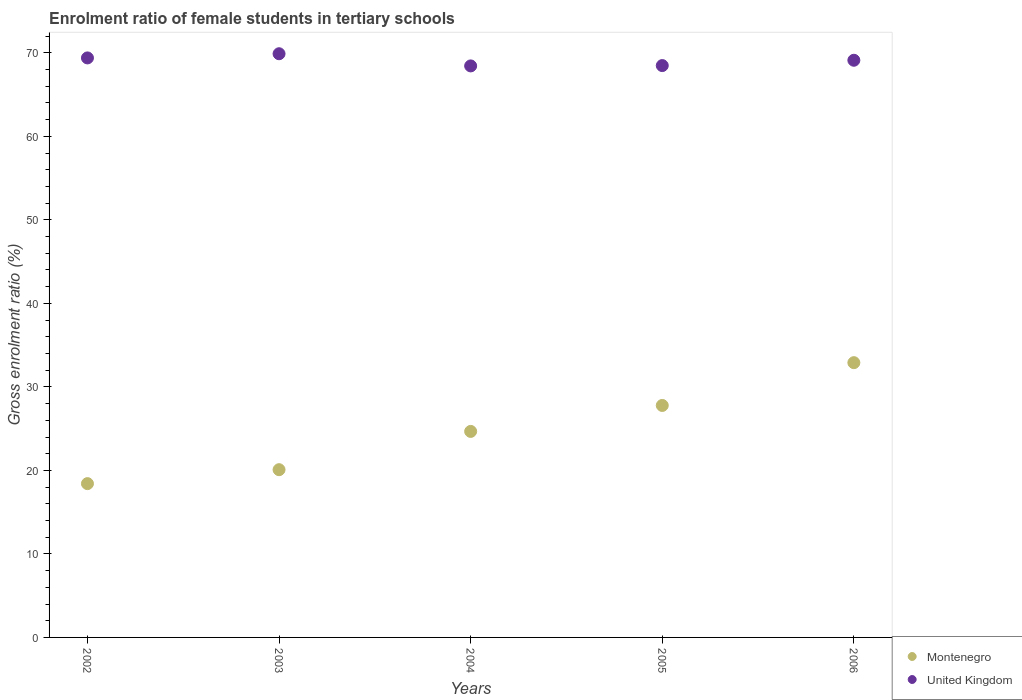Is the number of dotlines equal to the number of legend labels?
Ensure brevity in your answer.  Yes. What is the enrolment ratio of female students in tertiary schools in Montenegro in 2003?
Make the answer very short. 20.09. Across all years, what is the maximum enrolment ratio of female students in tertiary schools in United Kingdom?
Ensure brevity in your answer.  69.9. Across all years, what is the minimum enrolment ratio of female students in tertiary schools in Montenegro?
Make the answer very short. 18.42. In which year was the enrolment ratio of female students in tertiary schools in United Kingdom minimum?
Provide a succinct answer. 2004. What is the total enrolment ratio of female students in tertiary schools in United Kingdom in the graph?
Offer a terse response. 345.32. What is the difference between the enrolment ratio of female students in tertiary schools in Montenegro in 2002 and that in 2003?
Your answer should be compact. -1.67. What is the difference between the enrolment ratio of female students in tertiary schools in Montenegro in 2002 and the enrolment ratio of female students in tertiary schools in United Kingdom in 2003?
Make the answer very short. -51.48. What is the average enrolment ratio of female students in tertiary schools in United Kingdom per year?
Offer a terse response. 69.06. In the year 2003, what is the difference between the enrolment ratio of female students in tertiary schools in United Kingdom and enrolment ratio of female students in tertiary schools in Montenegro?
Offer a very short reply. 49.81. What is the ratio of the enrolment ratio of female students in tertiary schools in United Kingdom in 2003 to that in 2006?
Your response must be concise. 1.01. What is the difference between the highest and the second highest enrolment ratio of female students in tertiary schools in Montenegro?
Offer a terse response. 5.12. What is the difference between the highest and the lowest enrolment ratio of female students in tertiary schools in Montenegro?
Provide a succinct answer. 14.49. In how many years, is the enrolment ratio of female students in tertiary schools in United Kingdom greater than the average enrolment ratio of female students in tertiary schools in United Kingdom taken over all years?
Your answer should be compact. 3. Is the sum of the enrolment ratio of female students in tertiary schools in Montenegro in 2003 and 2005 greater than the maximum enrolment ratio of female students in tertiary schools in United Kingdom across all years?
Your answer should be compact. No. Does the enrolment ratio of female students in tertiary schools in United Kingdom monotonically increase over the years?
Offer a very short reply. No. How many dotlines are there?
Your response must be concise. 2. How many years are there in the graph?
Your response must be concise. 5. What is the difference between two consecutive major ticks on the Y-axis?
Keep it short and to the point. 10. Are the values on the major ticks of Y-axis written in scientific E-notation?
Offer a terse response. No. Does the graph contain any zero values?
Your response must be concise. No. Does the graph contain grids?
Your answer should be compact. No. How many legend labels are there?
Give a very brief answer. 2. What is the title of the graph?
Make the answer very short. Enrolment ratio of female students in tertiary schools. Does "Sudan" appear as one of the legend labels in the graph?
Your response must be concise. No. What is the label or title of the Y-axis?
Offer a very short reply. Gross enrolment ratio (%). What is the Gross enrolment ratio (%) in Montenegro in 2002?
Your response must be concise. 18.42. What is the Gross enrolment ratio (%) of United Kingdom in 2002?
Offer a very short reply. 69.4. What is the Gross enrolment ratio (%) of Montenegro in 2003?
Your response must be concise. 20.09. What is the Gross enrolment ratio (%) of United Kingdom in 2003?
Provide a succinct answer. 69.9. What is the Gross enrolment ratio (%) of Montenegro in 2004?
Keep it short and to the point. 24.67. What is the Gross enrolment ratio (%) in United Kingdom in 2004?
Make the answer very short. 68.44. What is the Gross enrolment ratio (%) of Montenegro in 2005?
Give a very brief answer. 27.78. What is the Gross enrolment ratio (%) of United Kingdom in 2005?
Offer a terse response. 68.48. What is the Gross enrolment ratio (%) in Montenegro in 2006?
Keep it short and to the point. 32.9. What is the Gross enrolment ratio (%) of United Kingdom in 2006?
Give a very brief answer. 69.11. Across all years, what is the maximum Gross enrolment ratio (%) of Montenegro?
Provide a succinct answer. 32.9. Across all years, what is the maximum Gross enrolment ratio (%) of United Kingdom?
Give a very brief answer. 69.9. Across all years, what is the minimum Gross enrolment ratio (%) of Montenegro?
Make the answer very short. 18.42. Across all years, what is the minimum Gross enrolment ratio (%) of United Kingdom?
Keep it short and to the point. 68.44. What is the total Gross enrolment ratio (%) in Montenegro in the graph?
Your answer should be compact. 123.85. What is the total Gross enrolment ratio (%) of United Kingdom in the graph?
Ensure brevity in your answer.  345.32. What is the difference between the Gross enrolment ratio (%) in Montenegro in 2002 and that in 2003?
Your answer should be very brief. -1.67. What is the difference between the Gross enrolment ratio (%) of United Kingdom in 2002 and that in 2003?
Your answer should be compact. -0.5. What is the difference between the Gross enrolment ratio (%) of Montenegro in 2002 and that in 2004?
Keep it short and to the point. -6.25. What is the difference between the Gross enrolment ratio (%) in United Kingdom in 2002 and that in 2004?
Your answer should be very brief. 0.96. What is the difference between the Gross enrolment ratio (%) of Montenegro in 2002 and that in 2005?
Make the answer very short. -9.36. What is the difference between the Gross enrolment ratio (%) of United Kingdom in 2002 and that in 2005?
Offer a terse response. 0.92. What is the difference between the Gross enrolment ratio (%) of Montenegro in 2002 and that in 2006?
Offer a terse response. -14.49. What is the difference between the Gross enrolment ratio (%) of United Kingdom in 2002 and that in 2006?
Your response must be concise. 0.28. What is the difference between the Gross enrolment ratio (%) in Montenegro in 2003 and that in 2004?
Your answer should be very brief. -4.58. What is the difference between the Gross enrolment ratio (%) of United Kingdom in 2003 and that in 2004?
Keep it short and to the point. 1.46. What is the difference between the Gross enrolment ratio (%) of Montenegro in 2003 and that in 2005?
Make the answer very short. -7.69. What is the difference between the Gross enrolment ratio (%) in United Kingdom in 2003 and that in 2005?
Offer a very short reply. 1.42. What is the difference between the Gross enrolment ratio (%) in Montenegro in 2003 and that in 2006?
Provide a short and direct response. -12.82. What is the difference between the Gross enrolment ratio (%) of United Kingdom in 2003 and that in 2006?
Keep it short and to the point. 0.78. What is the difference between the Gross enrolment ratio (%) in Montenegro in 2004 and that in 2005?
Provide a succinct answer. -3.11. What is the difference between the Gross enrolment ratio (%) in United Kingdom in 2004 and that in 2005?
Keep it short and to the point. -0.04. What is the difference between the Gross enrolment ratio (%) in Montenegro in 2004 and that in 2006?
Provide a succinct answer. -8.23. What is the difference between the Gross enrolment ratio (%) in United Kingdom in 2004 and that in 2006?
Your answer should be very brief. -0.68. What is the difference between the Gross enrolment ratio (%) in Montenegro in 2005 and that in 2006?
Your answer should be compact. -5.12. What is the difference between the Gross enrolment ratio (%) of United Kingdom in 2005 and that in 2006?
Provide a succinct answer. -0.64. What is the difference between the Gross enrolment ratio (%) of Montenegro in 2002 and the Gross enrolment ratio (%) of United Kingdom in 2003?
Offer a very short reply. -51.48. What is the difference between the Gross enrolment ratio (%) in Montenegro in 2002 and the Gross enrolment ratio (%) in United Kingdom in 2004?
Offer a very short reply. -50.02. What is the difference between the Gross enrolment ratio (%) of Montenegro in 2002 and the Gross enrolment ratio (%) of United Kingdom in 2005?
Provide a short and direct response. -50.06. What is the difference between the Gross enrolment ratio (%) of Montenegro in 2002 and the Gross enrolment ratio (%) of United Kingdom in 2006?
Offer a very short reply. -50.7. What is the difference between the Gross enrolment ratio (%) in Montenegro in 2003 and the Gross enrolment ratio (%) in United Kingdom in 2004?
Your answer should be compact. -48.35. What is the difference between the Gross enrolment ratio (%) in Montenegro in 2003 and the Gross enrolment ratio (%) in United Kingdom in 2005?
Provide a short and direct response. -48.39. What is the difference between the Gross enrolment ratio (%) in Montenegro in 2003 and the Gross enrolment ratio (%) in United Kingdom in 2006?
Provide a succinct answer. -49.03. What is the difference between the Gross enrolment ratio (%) in Montenegro in 2004 and the Gross enrolment ratio (%) in United Kingdom in 2005?
Offer a very short reply. -43.81. What is the difference between the Gross enrolment ratio (%) of Montenegro in 2004 and the Gross enrolment ratio (%) of United Kingdom in 2006?
Keep it short and to the point. -44.44. What is the difference between the Gross enrolment ratio (%) in Montenegro in 2005 and the Gross enrolment ratio (%) in United Kingdom in 2006?
Keep it short and to the point. -41.34. What is the average Gross enrolment ratio (%) of Montenegro per year?
Your answer should be very brief. 24.77. What is the average Gross enrolment ratio (%) in United Kingdom per year?
Offer a terse response. 69.06. In the year 2002, what is the difference between the Gross enrolment ratio (%) in Montenegro and Gross enrolment ratio (%) in United Kingdom?
Offer a very short reply. -50.98. In the year 2003, what is the difference between the Gross enrolment ratio (%) of Montenegro and Gross enrolment ratio (%) of United Kingdom?
Provide a short and direct response. -49.81. In the year 2004, what is the difference between the Gross enrolment ratio (%) in Montenegro and Gross enrolment ratio (%) in United Kingdom?
Ensure brevity in your answer.  -43.77. In the year 2005, what is the difference between the Gross enrolment ratio (%) of Montenegro and Gross enrolment ratio (%) of United Kingdom?
Give a very brief answer. -40.7. In the year 2006, what is the difference between the Gross enrolment ratio (%) in Montenegro and Gross enrolment ratio (%) in United Kingdom?
Provide a short and direct response. -36.21. What is the ratio of the Gross enrolment ratio (%) in Montenegro in 2002 to that in 2003?
Your answer should be very brief. 0.92. What is the ratio of the Gross enrolment ratio (%) of United Kingdom in 2002 to that in 2003?
Provide a short and direct response. 0.99. What is the ratio of the Gross enrolment ratio (%) of Montenegro in 2002 to that in 2004?
Your answer should be very brief. 0.75. What is the ratio of the Gross enrolment ratio (%) of Montenegro in 2002 to that in 2005?
Make the answer very short. 0.66. What is the ratio of the Gross enrolment ratio (%) in United Kingdom in 2002 to that in 2005?
Make the answer very short. 1.01. What is the ratio of the Gross enrolment ratio (%) in Montenegro in 2002 to that in 2006?
Provide a succinct answer. 0.56. What is the ratio of the Gross enrolment ratio (%) in Montenegro in 2003 to that in 2004?
Make the answer very short. 0.81. What is the ratio of the Gross enrolment ratio (%) of United Kingdom in 2003 to that in 2004?
Your response must be concise. 1.02. What is the ratio of the Gross enrolment ratio (%) in Montenegro in 2003 to that in 2005?
Your answer should be compact. 0.72. What is the ratio of the Gross enrolment ratio (%) of United Kingdom in 2003 to that in 2005?
Keep it short and to the point. 1.02. What is the ratio of the Gross enrolment ratio (%) of Montenegro in 2003 to that in 2006?
Provide a short and direct response. 0.61. What is the ratio of the Gross enrolment ratio (%) of United Kingdom in 2003 to that in 2006?
Make the answer very short. 1.01. What is the ratio of the Gross enrolment ratio (%) of Montenegro in 2004 to that in 2005?
Your answer should be very brief. 0.89. What is the ratio of the Gross enrolment ratio (%) in United Kingdom in 2004 to that in 2005?
Offer a very short reply. 1. What is the ratio of the Gross enrolment ratio (%) of Montenegro in 2004 to that in 2006?
Your answer should be very brief. 0.75. What is the ratio of the Gross enrolment ratio (%) of United Kingdom in 2004 to that in 2006?
Ensure brevity in your answer.  0.99. What is the ratio of the Gross enrolment ratio (%) of Montenegro in 2005 to that in 2006?
Provide a short and direct response. 0.84. What is the difference between the highest and the second highest Gross enrolment ratio (%) of Montenegro?
Offer a very short reply. 5.12. What is the difference between the highest and the second highest Gross enrolment ratio (%) in United Kingdom?
Your answer should be compact. 0.5. What is the difference between the highest and the lowest Gross enrolment ratio (%) of Montenegro?
Offer a very short reply. 14.49. What is the difference between the highest and the lowest Gross enrolment ratio (%) in United Kingdom?
Offer a terse response. 1.46. 